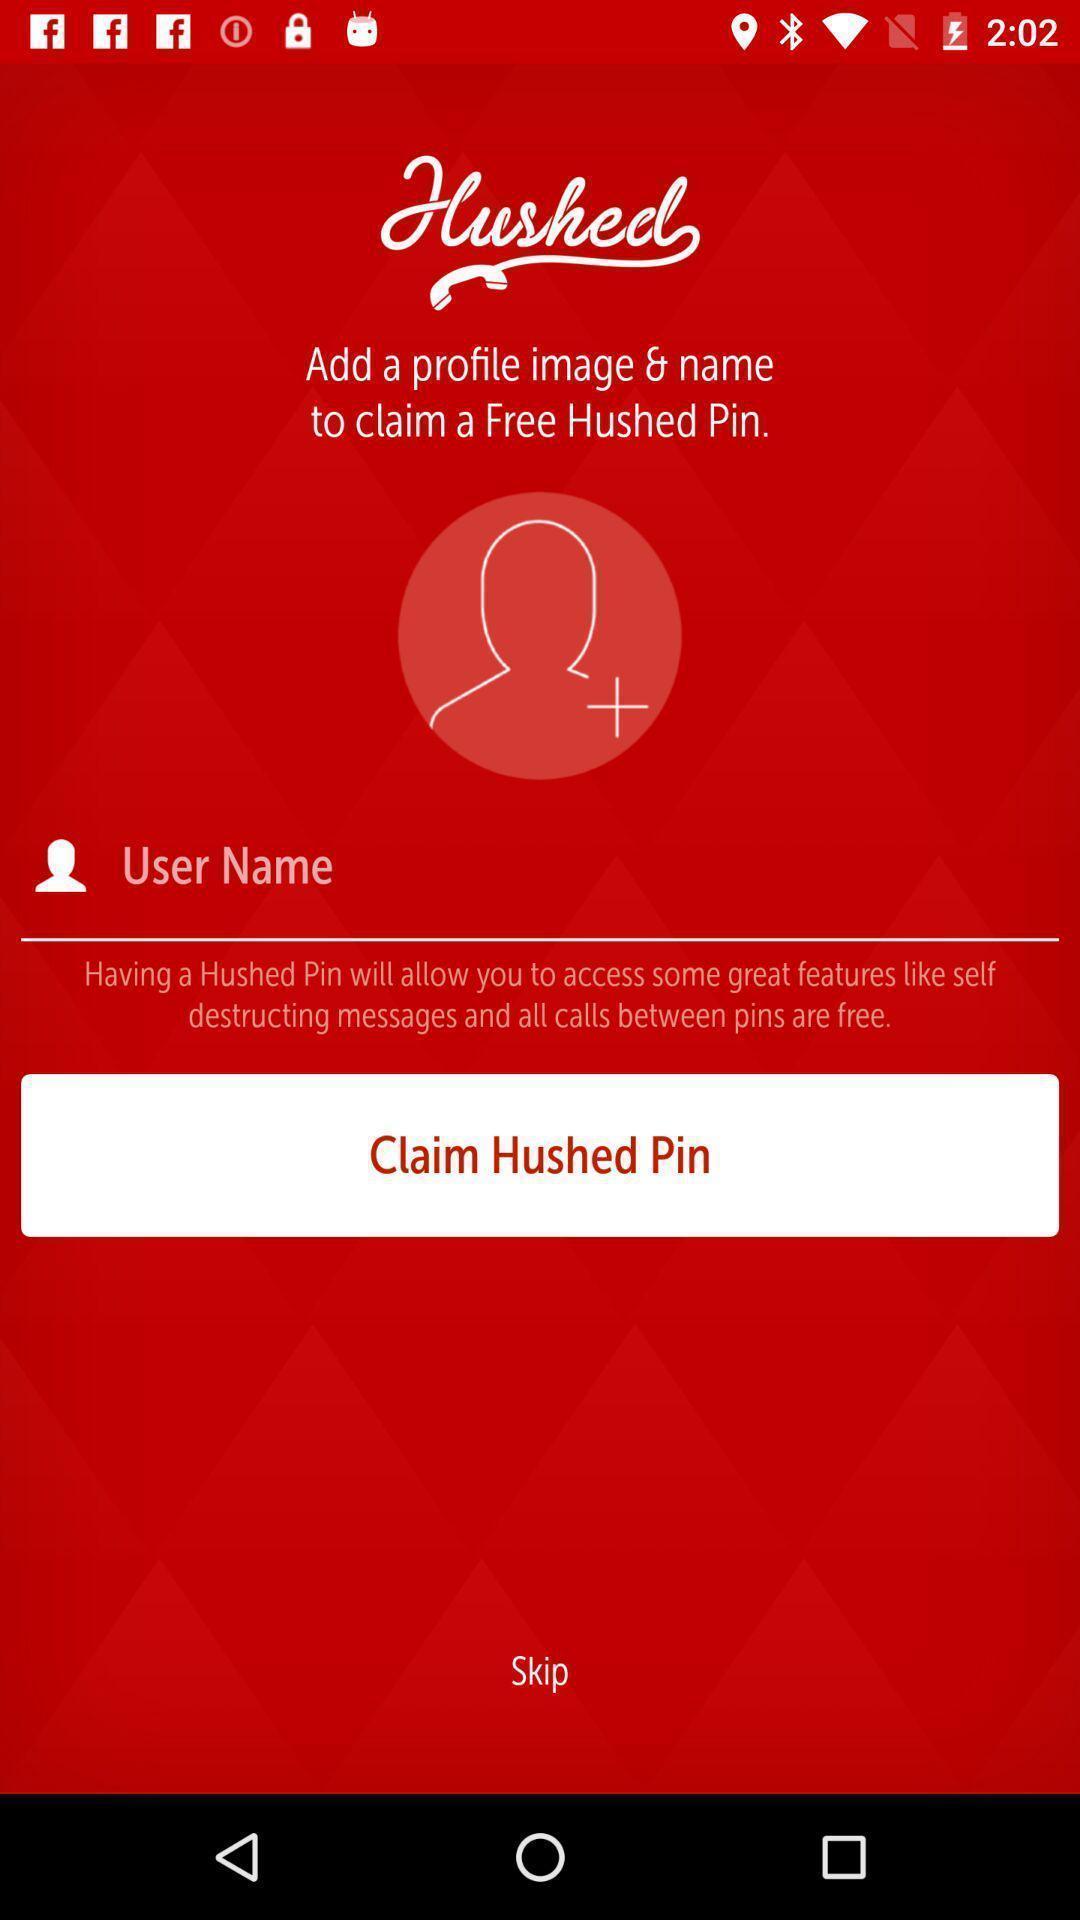What can you discern from this picture? Page showing enter user name. 